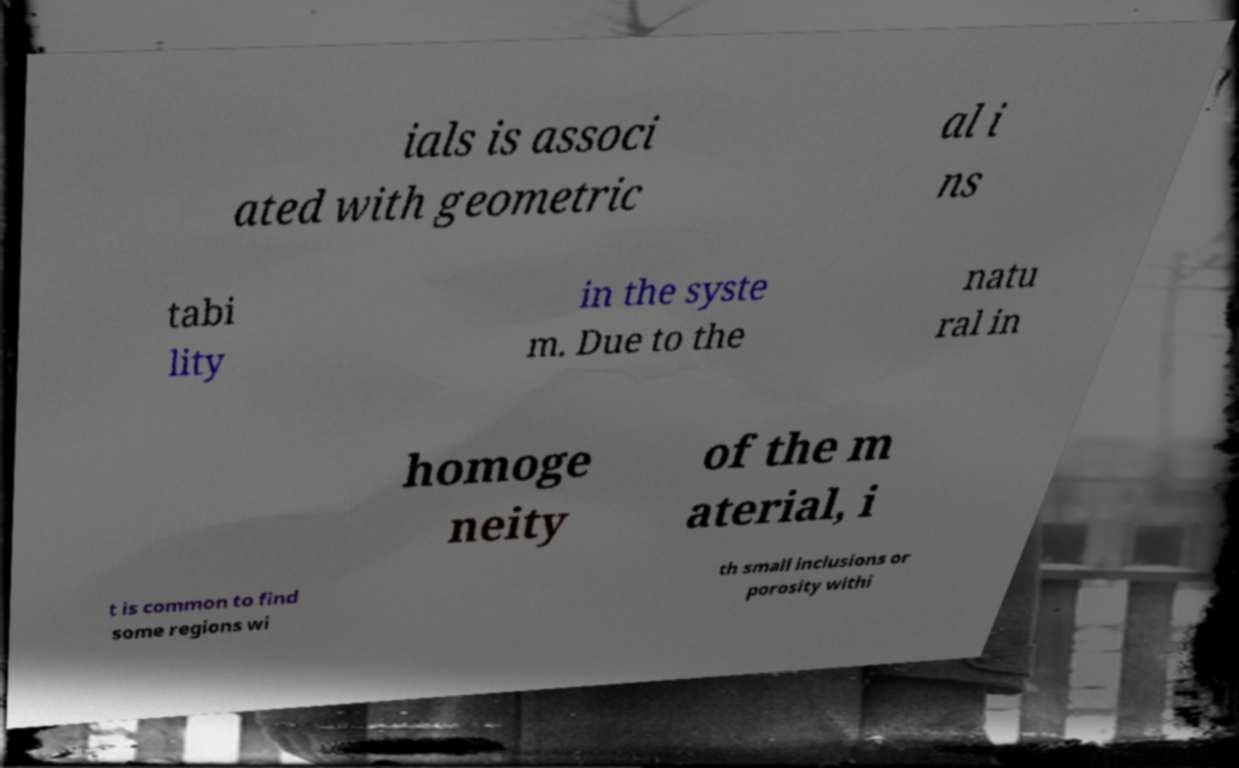Can you read and provide the text displayed in the image?This photo seems to have some interesting text. Can you extract and type it out for me? ials is associ ated with geometric al i ns tabi lity in the syste m. Due to the natu ral in homoge neity of the m aterial, i t is common to find some regions wi th small inclusions or porosity withi 